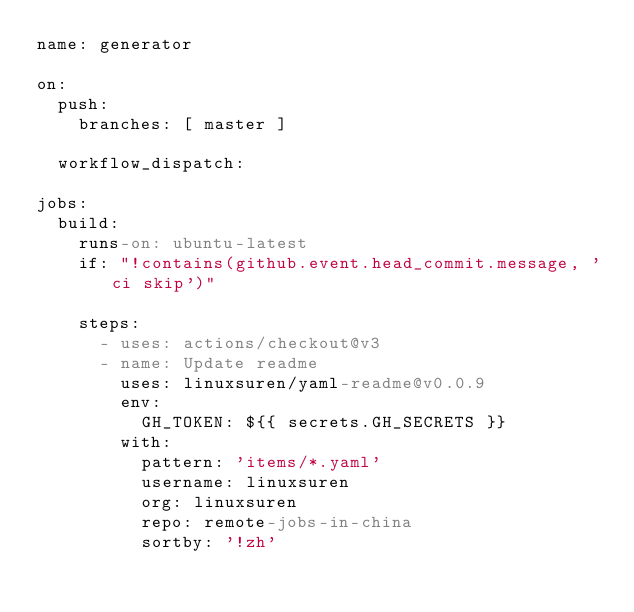Convert code to text. <code><loc_0><loc_0><loc_500><loc_500><_YAML_>name: generator

on:
  push:
    branches: [ master ]

  workflow_dispatch:

jobs:
  build:
    runs-on: ubuntu-latest
    if: "!contains(github.event.head_commit.message, 'ci skip')"

    steps:
      - uses: actions/checkout@v3
      - name: Update readme
        uses: linuxsuren/yaml-readme@v0.0.9
        env:
          GH_TOKEN: ${{ secrets.GH_SECRETS }}
        with:
          pattern: 'items/*.yaml'
          username: linuxsuren
          org: linuxsuren
          repo: remote-jobs-in-china
          sortby: '!zh'
</code> 